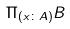<formula> <loc_0><loc_0><loc_500><loc_500>\Pi _ { ( x \colon A ) } B</formula> 